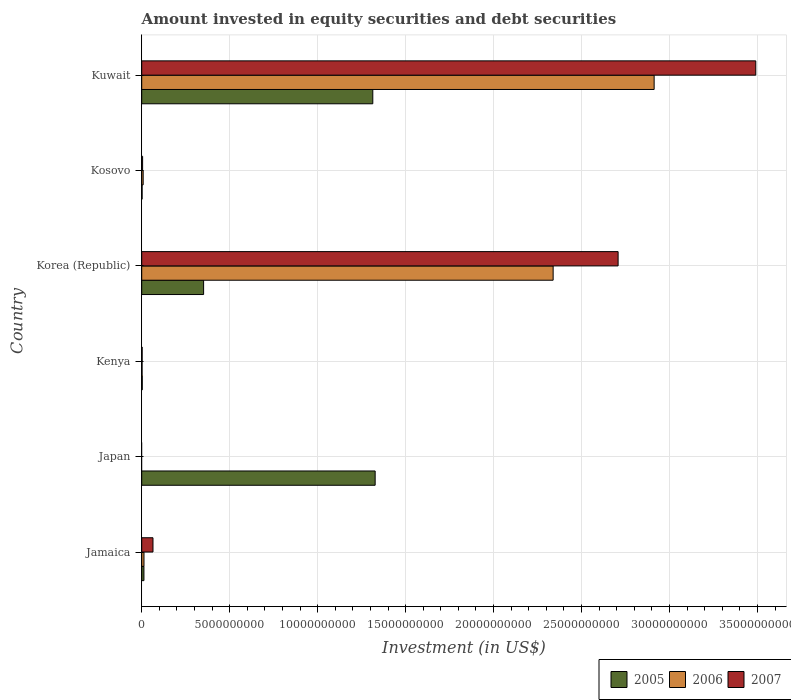Are the number of bars on each tick of the Y-axis equal?
Your response must be concise. No. What is the label of the 4th group of bars from the top?
Provide a succinct answer. Kenya. In how many cases, is the number of bars for a given country not equal to the number of legend labels?
Offer a terse response. 1. What is the amount invested in equity securities and debt securities in 2005 in Korea (Republic)?
Make the answer very short. 3.52e+09. Across all countries, what is the maximum amount invested in equity securities and debt securities in 2006?
Offer a terse response. 2.91e+1. Across all countries, what is the minimum amount invested in equity securities and debt securities in 2007?
Your answer should be compact. 0. What is the total amount invested in equity securities and debt securities in 2005 in the graph?
Give a very brief answer. 3.01e+1. What is the difference between the amount invested in equity securities and debt securities in 2006 in Jamaica and that in Kenya?
Ensure brevity in your answer.  1.08e+08. What is the difference between the amount invested in equity securities and debt securities in 2007 in Kenya and the amount invested in equity securities and debt securities in 2005 in Korea (Republic)?
Provide a succinct answer. -3.49e+09. What is the average amount invested in equity securities and debt securities in 2007 per country?
Offer a very short reply. 1.04e+1. What is the difference between the amount invested in equity securities and debt securities in 2007 and amount invested in equity securities and debt securities in 2006 in Jamaica?
Give a very brief answer. 5.12e+08. In how many countries, is the amount invested in equity securities and debt securities in 2007 greater than 21000000000 US$?
Ensure brevity in your answer.  2. What is the ratio of the amount invested in equity securities and debt securities in 2005 in Japan to that in Korea (Republic)?
Your answer should be very brief. 3.77. Is the amount invested in equity securities and debt securities in 2006 in Kenya less than that in Korea (Republic)?
Your response must be concise. Yes. Is the difference between the amount invested in equity securities and debt securities in 2007 in Korea (Republic) and Kosovo greater than the difference between the amount invested in equity securities and debt securities in 2006 in Korea (Republic) and Kosovo?
Provide a short and direct response. Yes. What is the difference between the highest and the second highest amount invested in equity securities and debt securities in 2006?
Keep it short and to the point. 5.74e+09. What is the difference between the highest and the lowest amount invested in equity securities and debt securities in 2007?
Provide a short and direct response. 3.49e+1. How many bars are there?
Offer a terse response. 16. How many countries are there in the graph?
Offer a very short reply. 6. What is the difference between two consecutive major ticks on the X-axis?
Offer a very short reply. 5.00e+09. Does the graph contain grids?
Your answer should be compact. Yes. Where does the legend appear in the graph?
Your answer should be compact. Bottom right. What is the title of the graph?
Make the answer very short. Amount invested in equity securities and debt securities. Does "1961" appear as one of the legend labels in the graph?
Offer a terse response. No. What is the label or title of the X-axis?
Ensure brevity in your answer.  Investment (in US$). What is the label or title of the Y-axis?
Make the answer very short. Country. What is the Investment (in US$) in 2005 in Jamaica?
Offer a very short reply. 1.26e+08. What is the Investment (in US$) in 2006 in Jamaica?
Your response must be concise. 1.29e+08. What is the Investment (in US$) in 2007 in Jamaica?
Ensure brevity in your answer.  6.40e+08. What is the Investment (in US$) in 2005 in Japan?
Your answer should be very brief. 1.33e+1. What is the Investment (in US$) in 2005 in Kenya?
Offer a terse response. 3.05e+07. What is the Investment (in US$) in 2006 in Kenya?
Ensure brevity in your answer.  2.06e+07. What is the Investment (in US$) of 2007 in Kenya?
Keep it short and to the point. 2.47e+07. What is the Investment (in US$) in 2005 in Korea (Republic)?
Give a very brief answer. 3.52e+09. What is the Investment (in US$) of 2006 in Korea (Republic)?
Keep it short and to the point. 2.34e+1. What is the Investment (in US$) in 2007 in Korea (Republic)?
Your answer should be compact. 2.71e+1. What is the Investment (in US$) of 2005 in Kosovo?
Provide a succinct answer. 2.18e+07. What is the Investment (in US$) of 2006 in Kosovo?
Provide a succinct answer. 8.20e+07. What is the Investment (in US$) of 2007 in Kosovo?
Keep it short and to the point. 5.01e+07. What is the Investment (in US$) of 2005 in Kuwait?
Offer a terse response. 1.31e+1. What is the Investment (in US$) of 2006 in Kuwait?
Offer a very short reply. 2.91e+1. What is the Investment (in US$) of 2007 in Kuwait?
Provide a short and direct response. 3.49e+1. Across all countries, what is the maximum Investment (in US$) in 2005?
Keep it short and to the point. 1.33e+1. Across all countries, what is the maximum Investment (in US$) of 2006?
Provide a succinct answer. 2.91e+1. Across all countries, what is the maximum Investment (in US$) of 2007?
Ensure brevity in your answer.  3.49e+1. Across all countries, what is the minimum Investment (in US$) in 2005?
Your answer should be very brief. 2.18e+07. Across all countries, what is the minimum Investment (in US$) of 2006?
Provide a succinct answer. 0. Across all countries, what is the minimum Investment (in US$) in 2007?
Your response must be concise. 0. What is the total Investment (in US$) in 2005 in the graph?
Offer a very short reply. 3.01e+1. What is the total Investment (in US$) in 2006 in the graph?
Offer a terse response. 5.27e+1. What is the total Investment (in US$) in 2007 in the graph?
Ensure brevity in your answer.  6.27e+1. What is the difference between the Investment (in US$) of 2005 in Jamaica and that in Japan?
Keep it short and to the point. -1.31e+1. What is the difference between the Investment (in US$) in 2005 in Jamaica and that in Kenya?
Your answer should be very brief. 9.55e+07. What is the difference between the Investment (in US$) in 2006 in Jamaica and that in Kenya?
Give a very brief answer. 1.08e+08. What is the difference between the Investment (in US$) of 2007 in Jamaica and that in Kenya?
Provide a succinct answer. 6.16e+08. What is the difference between the Investment (in US$) of 2005 in Jamaica and that in Korea (Republic)?
Give a very brief answer. -3.39e+09. What is the difference between the Investment (in US$) of 2006 in Jamaica and that in Korea (Republic)?
Ensure brevity in your answer.  -2.33e+1. What is the difference between the Investment (in US$) in 2007 in Jamaica and that in Korea (Republic)?
Keep it short and to the point. -2.64e+1. What is the difference between the Investment (in US$) of 2005 in Jamaica and that in Kosovo?
Give a very brief answer. 1.04e+08. What is the difference between the Investment (in US$) in 2006 in Jamaica and that in Kosovo?
Offer a very short reply. 4.65e+07. What is the difference between the Investment (in US$) in 2007 in Jamaica and that in Kosovo?
Ensure brevity in your answer.  5.90e+08. What is the difference between the Investment (in US$) in 2005 in Jamaica and that in Kuwait?
Give a very brief answer. -1.30e+1. What is the difference between the Investment (in US$) of 2006 in Jamaica and that in Kuwait?
Your response must be concise. -2.90e+1. What is the difference between the Investment (in US$) in 2007 in Jamaica and that in Kuwait?
Give a very brief answer. -3.43e+1. What is the difference between the Investment (in US$) in 2005 in Japan and that in Kenya?
Provide a short and direct response. 1.32e+1. What is the difference between the Investment (in US$) of 2005 in Japan and that in Korea (Republic)?
Give a very brief answer. 9.75e+09. What is the difference between the Investment (in US$) of 2005 in Japan and that in Kosovo?
Provide a succinct answer. 1.32e+1. What is the difference between the Investment (in US$) of 2005 in Japan and that in Kuwait?
Give a very brief answer. 1.34e+08. What is the difference between the Investment (in US$) in 2005 in Kenya and that in Korea (Republic)?
Provide a succinct answer. -3.49e+09. What is the difference between the Investment (in US$) in 2006 in Kenya and that in Korea (Republic)?
Offer a very short reply. -2.34e+1. What is the difference between the Investment (in US$) of 2007 in Kenya and that in Korea (Republic)?
Provide a succinct answer. -2.71e+1. What is the difference between the Investment (in US$) in 2005 in Kenya and that in Kosovo?
Make the answer very short. 8.69e+06. What is the difference between the Investment (in US$) of 2006 in Kenya and that in Kosovo?
Provide a short and direct response. -6.14e+07. What is the difference between the Investment (in US$) of 2007 in Kenya and that in Kosovo?
Ensure brevity in your answer.  -2.54e+07. What is the difference between the Investment (in US$) of 2005 in Kenya and that in Kuwait?
Keep it short and to the point. -1.31e+1. What is the difference between the Investment (in US$) of 2006 in Kenya and that in Kuwait?
Your response must be concise. -2.91e+1. What is the difference between the Investment (in US$) of 2007 in Kenya and that in Kuwait?
Give a very brief answer. -3.49e+1. What is the difference between the Investment (in US$) in 2005 in Korea (Republic) and that in Kosovo?
Provide a short and direct response. 3.50e+09. What is the difference between the Investment (in US$) in 2006 in Korea (Republic) and that in Kosovo?
Your answer should be compact. 2.33e+1. What is the difference between the Investment (in US$) in 2007 in Korea (Republic) and that in Kosovo?
Provide a succinct answer. 2.70e+1. What is the difference between the Investment (in US$) of 2005 in Korea (Republic) and that in Kuwait?
Your answer should be compact. -9.62e+09. What is the difference between the Investment (in US$) of 2006 in Korea (Republic) and that in Kuwait?
Your answer should be compact. -5.74e+09. What is the difference between the Investment (in US$) of 2007 in Korea (Republic) and that in Kuwait?
Provide a succinct answer. -7.83e+09. What is the difference between the Investment (in US$) in 2005 in Kosovo and that in Kuwait?
Ensure brevity in your answer.  -1.31e+1. What is the difference between the Investment (in US$) of 2006 in Kosovo and that in Kuwait?
Offer a very short reply. -2.90e+1. What is the difference between the Investment (in US$) in 2007 in Kosovo and that in Kuwait?
Keep it short and to the point. -3.49e+1. What is the difference between the Investment (in US$) of 2005 in Jamaica and the Investment (in US$) of 2006 in Kenya?
Offer a terse response. 1.05e+08. What is the difference between the Investment (in US$) in 2005 in Jamaica and the Investment (in US$) in 2007 in Kenya?
Give a very brief answer. 1.01e+08. What is the difference between the Investment (in US$) in 2006 in Jamaica and the Investment (in US$) in 2007 in Kenya?
Your response must be concise. 1.04e+08. What is the difference between the Investment (in US$) of 2005 in Jamaica and the Investment (in US$) of 2006 in Korea (Republic)?
Keep it short and to the point. -2.33e+1. What is the difference between the Investment (in US$) in 2005 in Jamaica and the Investment (in US$) in 2007 in Korea (Republic)?
Offer a very short reply. -2.70e+1. What is the difference between the Investment (in US$) in 2006 in Jamaica and the Investment (in US$) in 2007 in Korea (Republic)?
Provide a short and direct response. -2.69e+1. What is the difference between the Investment (in US$) of 2005 in Jamaica and the Investment (in US$) of 2006 in Kosovo?
Provide a succinct answer. 4.40e+07. What is the difference between the Investment (in US$) of 2005 in Jamaica and the Investment (in US$) of 2007 in Kosovo?
Keep it short and to the point. 7.59e+07. What is the difference between the Investment (in US$) in 2006 in Jamaica and the Investment (in US$) in 2007 in Kosovo?
Provide a succinct answer. 7.84e+07. What is the difference between the Investment (in US$) in 2005 in Jamaica and the Investment (in US$) in 2006 in Kuwait?
Your response must be concise. -2.90e+1. What is the difference between the Investment (in US$) of 2005 in Jamaica and the Investment (in US$) of 2007 in Kuwait?
Offer a terse response. -3.48e+1. What is the difference between the Investment (in US$) in 2006 in Jamaica and the Investment (in US$) in 2007 in Kuwait?
Your response must be concise. -3.48e+1. What is the difference between the Investment (in US$) of 2005 in Japan and the Investment (in US$) of 2006 in Kenya?
Keep it short and to the point. 1.32e+1. What is the difference between the Investment (in US$) of 2005 in Japan and the Investment (in US$) of 2007 in Kenya?
Offer a very short reply. 1.32e+1. What is the difference between the Investment (in US$) of 2005 in Japan and the Investment (in US$) of 2006 in Korea (Republic)?
Give a very brief answer. -1.01e+1. What is the difference between the Investment (in US$) of 2005 in Japan and the Investment (in US$) of 2007 in Korea (Republic)?
Offer a terse response. -1.38e+1. What is the difference between the Investment (in US$) of 2005 in Japan and the Investment (in US$) of 2006 in Kosovo?
Ensure brevity in your answer.  1.32e+1. What is the difference between the Investment (in US$) of 2005 in Japan and the Investment (in US$) of 2007 in Kosovo?
Provide a succinct answer. 1.32e+1. What is the difference between the Investment (in US$) in 2005 in Japan and the Investment (in US$) in 2006 in Kuwait?
Provide a succinct answer. -1.59e+1. What is the difference between the Investment (in US$) of 2005 in Japan and the Investment (in US$) of 2007 in Kuwait?
Offer a very short reply. -2.16e+1. What is the difference between the Investment (in US$) in 2005 in Kenya and the Investment (in US$) in 2006 in Korea (Republic)?
Offer a very short reply. -2.34e+1. What is the difference between the Investment (in US$) of 2005 in Kenya and the Investment (in US$) of 2007 in Korea (Republic)?
Ensure brevity in your answer.  -2.70e+1. What is the difference between the Investment (in US$) in 2006 in Kenya and the Investment (in US$) in 2007 in Korea (Republic)?
Your answer should be compact. -2.71e+1. What is the difference between the Investment (in US$) in 2005 in Kenya and the Investment (in US$) in 2006 in Kosovo?
Give a very brief answer. -5.16e+07. What is the difference between the Investment (in US$) in 2005 in Kenya and the Investment (in US$) in 2007 in Kosovo?
Provide a succinct answer. -1.96e+07. What is the difference between the Investment (in US$) in 2006 in Kenya and the Investment (in US$) in 2007 in Kosovo?
Your answer should be very brief. -2.95e+07. What is the difference between the Investment (in US$) in 2005 in Kenya and the Investment (in US$) in 2006 in Kuwait?
Ensure brevity in your answer.  -2.91e+1. What is the difference between the Investment (in US$) in 2005 in Kenya and the Investment (in US$) in 2007 in Kuwait?
Ensure brevity in your answer.  -3.49e+1. What is the difference between the Investment (in US$) of 2006 in Kenya and the Investment (in US$) of 2007 in Kuwait?
Keep it short and to the point. -3.49e+1. What is the difference between the Investment (in US$) in 2005 in Korea (Republic) and the Investment (in US$) in 2006 in Kosovo?
Offer a terse response. 3.44e+09. What is the difference between the Investment (in US$) in 2005 in Korea (Republic) and the Investment (in US$) in 2007 in Kosovo?
Provide a short and direct response. 3.47e+09. What is the difference between the Investment (in US$) of 2006 in Korea (Republic) and the Investment (in US$) of 2007 in Kosovo?
Ensure brevity in your answer.  2.33e+1. What is the difference between the Investment (in US$) of 2005 in Korea (Republic) and the Investment (in US$) of 2006 in Kuwait?
Ensure brevity in your answer.  -2.56e+1. What is the difference between the Investment (in US$) in 2005 in Korea (Republic) and the Investment (in US$) in 2007 in Kuwait?
Your answer should be compact. -3.14e+1. What is the difference between the Investment (in US$) in 2006 in Korea (Republic) and the Investment (in US$) in 2007 in Kuwait?
Give a very brief answer. -1.15e+1. What is the difference between the Investment (in US$) of 2005 in Kosovo and the Investment (in US$) of 2006 in Kuwait?
Provide a short and direct response. -2.91e+1. What is the difference between the Investment (in US$) in 2005 in Kosovo and the Investment (in US$) in 2007 in Kuwait?
Offer a very short reply. -3.49e+1. What is the difference between the Investment (in US$) in 2006 in Kosovo and the Investment (in US$) in 2007 in Kuwait?
Give a very brief answer. -3.48e+1. What is the average Investment (in US$) of 2005 per country?
Make the answer very short. 5.02e+09. What is the average Investment (in US$) of 2006 per country?
Keep it short and to the point. 8.79e+09. What is the average Investment (in US$) of 2007 per country?
Offer a terse response. 1.04e+1. What is the difference between the Investment (in US$) of 2005 and Investment (in US$) of 2006 in Jamaica?
Provide a short and direct response. -2.52e+06. What is the difference between the Investment (in US$) in 2005 and Investment (in US$) in 2007 in Jamaica?
Provide a succinct answer. -5.14e+08. What is the difference between the Investment (in US$) in 2006 and Investment (in US$) in 2007 in Jamaica?
Offer a terse response. -5.12e+08. What is the difference between the Investment (in US$) of 2005 and Investment (in US$) of 2006 in Kenya?
Keep it short and to the point. 9.84e+06. What is the difference between the Investment (in US$) of 2005 and Investment (in US$) of 2007 in Kenya?
Provide a succinct answer. 5.74e+06. What is the difference between the Investment (in US$) of 2006 and Investment (in US$) of 2007 in Kenya?
Offer a very short reply. -4.10e+06. What is the difference between the Investment (in US$) of 2005 and Investment (in US$) of 2006 in Korea (Republic)?
Offer a terse response. -1.99e+1. What is the difference between the Investment (in US$) in 2005 and Investment (in US$) in 2007 in Korea (Republic)?
Provide a short and direct response. -2.36e+1. What is the difference between the Investment (in US$) of 2006 and Investment (in US$) of 2007 in Korea (Republic)?
Offer a terse response. -3.69e+09. What is the difference between the Investment (in US$) in 2005 and Investment (in US$) in 2006 in Kosovo?
Your response must be concise. -6.03e+07. What is the difference between the Investment (in US$) in 2005 and Investment (in US$) in 2007 in Kosovo?
Offer a very short reply. -2.83e+07. What is the difference between the Investment (in US$) of 2006 and Investment (in US$) of 2007 in Kosovo?
Ensure brevity in your answer.  3.19e+07. What is the difference between the Investment (in US$) in 2005 and Investment (in US$) in 2006 in Kuwait?
Give a very brief answer. -1.60e+1. What is the difference between the Investment (in US$) in 2005 and Investment (in US$) in 2007 in Kuwait?
Offer a very short reply. -2.18e+1. What is the difference between the Investment (in US$) in 2006 and Investment (in US$) in 2007 in Kuwait?
Make the answer very short. -5.78e+09. What is the ratio of the Investment (in US$) of 2005 in Jamaica to that in Japan?
Offer a very short reply. 0.01. What is the ratio of the Investment (in US$) in 2005 in Jamaica to that in Kenya?
Provide a short and direct response. 4.14. What is the ratio of the Investment (in US$) of 2006 in Jamaica to that in Kenya?
Make the answer very short. 6.23. What is the ratio of the Investment (in US$) in 2007 in Jamaica to that in Kenya?
Provide a succinct answer. 25.9. What is the ratio of the Investment (in US$) of 2005 in Jamaica to that in Korea (Republic)?
Your answer should be very brief. 0.04. What is the ratio of the Investment (in US$) in 2006 in Jamaica to that in Korea (Republic)?
Make the answer very short. 0.01. What is the ratio of the Investment (in US$) of 2007 in Jamaica to that in Korea (Republic)?
Offer a terse response. 0.02. What is the ratio of the Investment (in US$) of 2005 in Jamaica to that in Kosovo?
Provide a short and direct response. 5.79. What is the ratio of the Investment (in US$) of 2006 in Jamaica to that in Kosovo?
Offer a terse response. 1.57. What is the ratio of the Investment (in US$) in 2007 in Jamaica to that in Kosovo?
Provide a short and direct response. 12.78. What is the ratio of the Investment (in US$) of 2005 in Jamaica to that in Kuwait?
Provide a short and direct response. 0.01. What is the ratio of the Investment (in US$) in 2006 in Jamaica to that in Kuwait?
Your answer should be very brief. 0. What is the ratio of the Investment (in US$) in 2007 in Jamaica to that in Kuwait?
Give a very brief answer. 0.02. What is the ratio of the Investment (in US$) in 2005 in Japan to that in Kenya?
Provide a succinct answer. 435.55. What is the ratio of the Investment (in US$) of 2005 in Japan to that in Korea (Republic)?
Offer a very short reply. 3.77. What is the ratio of the Investment (in US$) in 2005 in Japan to that in Kosovo?
Offer a terse response. 609.37. What is the ratio of the Investment (in US$) in 2005 in Japan to that in Kuwait?
Make the answer very short. 1.01. What is the ratio of the Investment (in US$) in 2005 in Kenya to that in Korea (Republic)?
Offer a terse response. 0.01. What is the ratio of the Investment (in US$) in 2006 in Kenya to that in Korea (Republic)?
Your answer should be compact. 0. What is the ratio of the Investment (in US$) in 2007 in Kenya to that in Korea (Republic)?
Your answer should be compact. 0. What is the ratio of the Investment (in US$) of 2005 in Kenya to that in Kosovo?
Provide a succinct answer. 1.4. What is the ratio of the Investment (in US$) in 2006 in Kenya to that in Kosovo?
Provide a succinct answer. 0.25. What is the ratio of the Investment (in US$) in 2007 in Kenya to that in Kosovo?
Your response must be concise. 0.49. What is the ratio of the Investment (in US$) of 2005 in Kenya to that in Kuwait?
Offer a very short reply. 0. What is the ratio of the Investment (in US$) of 2006 in Kenya to that in Kuwait?
Make the answer very short. 0. What is the ratio of the Investment (in US$) in 2007 in Kenya to that in Kuwait?
Your answer should be very brief. 0. What is the ratio of the Investment (in US$) of 2005 in Korea (Republic) to that in Kosovo?
Your answer should be compact. 161.57. What is the ratio of the Investment (in US$) in 2006 in Korea (Republic) to that in Kosovo?
Your answer should be compact. 285.09. What is the ratio of the Investment (in US$) of 2007 in Korea (Republic) to that in Kosovo?
Provide a succinct answer. 540.52. What is the ratio of the Investment (in US$) of 2005 in Korea (Republic) to that in Kuwait?
Provide a succinct answer. 0.27. What is the ratio of the Investment (in US$) in 2006 in Korea (Republic) to that in Kuwait?
Give a very brief answer. 0.8. What is the ratio of the Investment (in US$) of 2007 in Korea (Republic) to that in Kuwait?
Offer a terse response. 0.78. What is the ratio of the Investment (in US$) of 2005 in Kosovo to that in Kuwait?
Your answer should be compact. 0. What is the ratio of the Investment (in US$) of 2006 in Kosovo to that in Kuwait?
Your answer should be very brief. 0. What is the ratio of the Investment (in US$) of 2007 in Kosovo to that in Kuwait?
Ensure brevity in your answer.  0. What is the difference between the highest and the second highest Investment (in US$) in 2005?
Provide a short and direct response. 1.34e+08. What is the difference between the highest and the second highest Investment (in US$) of 2006?
Your response must be concise. 5.74e+09. What is the difference between the highest and the second highest Investment (in US$) of 2007?
Offer a terse response. 7.83e+09. What is the difference between the highest and the lowest Investment (in US$) of 2005?
Offer a very short reply. 1.32e+1. What is the difference between the highest and the lowest Investment (in US$) of 2006?
Your answer should be compact. 2.91e+1. What is the difference between the highest and the lowest Investment (in US$) in 2007?
Provide a succinct answer. 3.49e+1. 